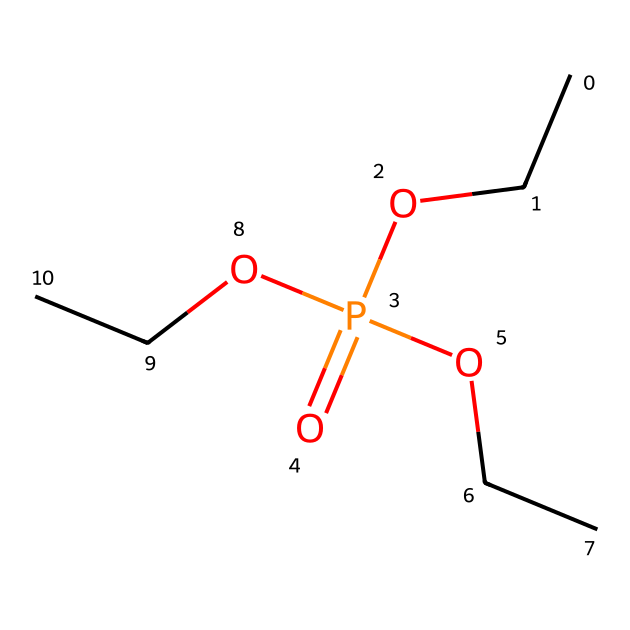What is the molecular formula of triethyl phosphate? The SMILES representation CCOP(=O)(OCC)OCC allows us to deduce the molecular formula. The compound contains three ethyl groups, one phosphorus atom, and four oxygen atoms, thus forming the formula C6H15O4P.
Answer: C6H15O4P How many ethyl groups are present in triethyl phosphate? In the SMILES, each ethyl group is represented as "CC," and there are three "CC" segments connected to the phosphorus atom.
Answer: three What is the total number of oxygen atoms in triethyl phosphate? The SMILES structure shows "O" and "OCC" (where OCC contributes one oxygen) appearing a total of four times: one from the phosphate functional group and three from the ethyl groups.
Answer: four Is triethyl phosphate a type of ester? The structure contains a phosphorus atom with ethyl groups bonded to it, which points to the fact that it forms a phosphate ester. This classification validates it as an ester type.
Answer: yes What is the role of triethyl phosphate in stage curtains? Triethyl phosphate is used as a fire retardant, as it helps to slow down or prevent combustion when applied to materials such as stage curtains.
Answer: fire retardant How many bonds connect the phosphorus to oxygen in triethyl phosphate? Analyzing the connections in the SMILES notation shows that phosphorus is directly bonded to four oxygen atoms: one double bond and three single bonds, totaling four connections.
Answer: four 